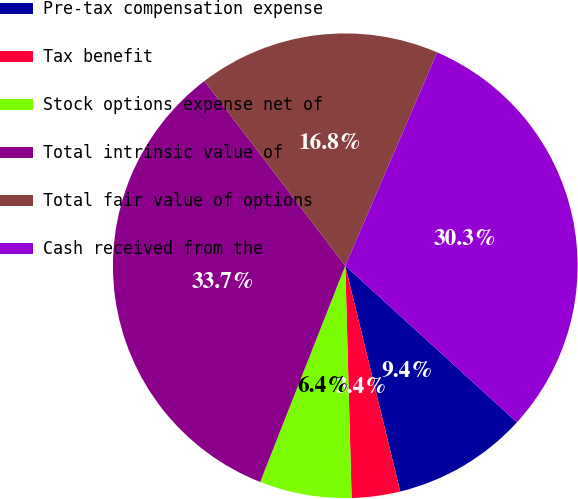Convert chart. <chart><loc_0><loc_0><loc_500><loc_500><pie_chart><fcel>Pre-tax compensation expense<fcel>Tax benefit<fcel>Stock options expense net of<fcel>Total intrinsic value of<fcel>Total fair value of options<fcel>Cash received from the<nl><fcel>9.43%<fcel>3.37%<fcel>6.4%<fcel>33.67%<fcel>16.84%<fcel>30.3%<nl></chart> 